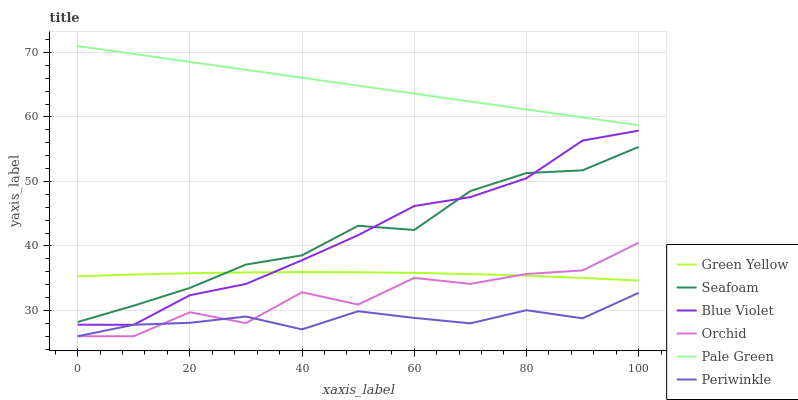Does Periwinkle have the minimum area under the curve?
Answer yes or no. Yes. Does Pale Green have the maximum area under the curve?
Answer yes or no. Yes. Does Pale Green have the minimum area under the curve?
Answer yes or no. No. Does Periwinkle have the maximum area under the curve?
Answer yes or no. No. Is Pale Green the smoothest?
Answer yes or no. Yes. Is Orchid the roughest?
Answer yes or no. Yes. Is Periwinkle the smoothest?
Answer yes or no. No. Is Periwinkle the roughest?
Answer yes or no. No. Does Periwinkle have the lowest value?
Answer yes or no. Yes. Does Pale Green have the lowest value?
Answer yes or no. No. Does Pale Green have the highest value?
Answer yes or no. Yes. Does Periwinkle have the highest value?
Answer yes or no. No. Is Green Yellow less than Pale Green?
Answer yes or no. Yes. Is Pale Green greater than Periwinkle?
Answer yes or no. Yes. Does Orchid intersect Periwinkle?
Answer yes or no. Yes. Is Orchid less than Periwinkle?
Answer yes or no. No. Is Orchid greater than Periwinkle?
Answer yes or no. No. Does Green Yellow intersect Pale Green?
Answer yes or no. No. 